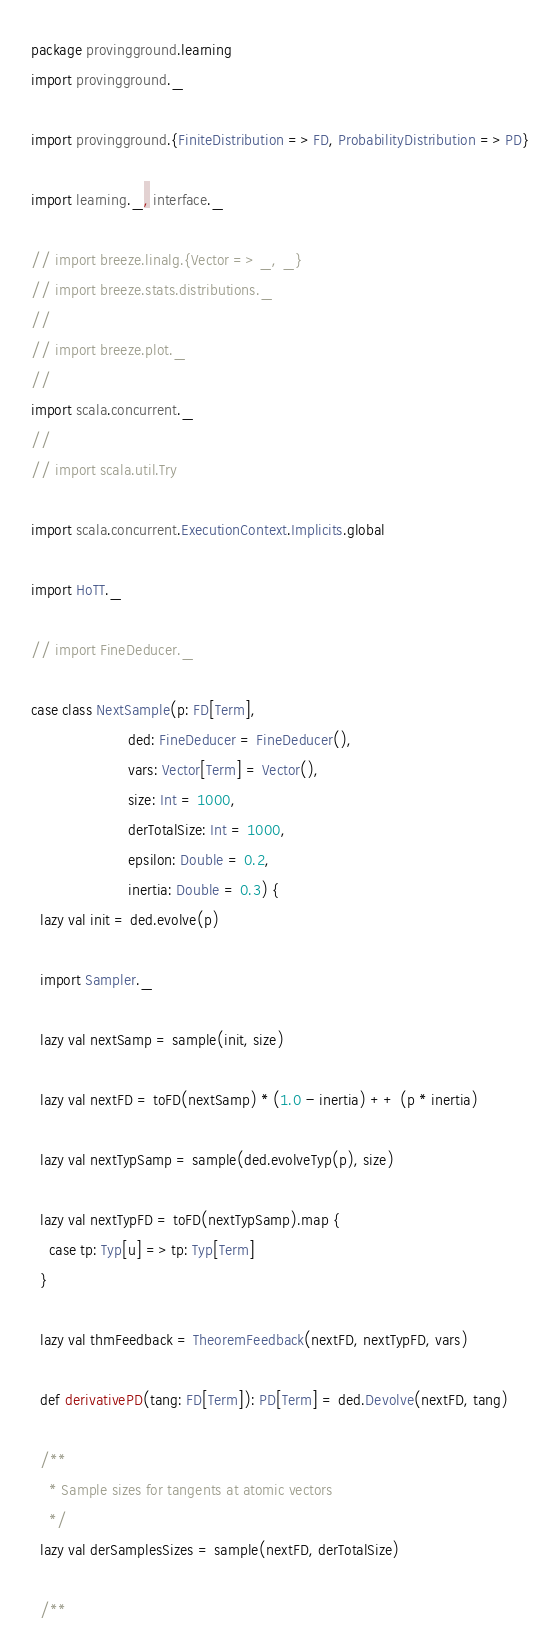Convert code to text. <code><loc_0><loc_0><loc_500><loc_500><_Scala_>package provingground.learning
import provingground._

import provingground.{FiniteDistribution => FD, ProbabilityDistribution => PD}

import learning._, interface._

// import breeze.linalg.{Vector => _, _}
// import breeze.stats.distributions._
//
// import breeze.plot._
//
import scala.concurrent._
//
// import scala.util.Try

import scala.concurrent.ExecutionContext.Implicits.global

import HoTT._

// import FineDeducer._

case class NextSample(p: FD[Term],
                      ded: FineDeducer = FineDeducer(),
                      vars: Vector[Term] = Vector(),
                      size: Int = 1000,
                      derTotalSize: Int = 1000,
                      epsilon: Double = 0.2,
                      inertia: Double = 0.3) {
  lazy val init = ded.evolve(p)

  import Sampler._

  lazy val nextSamp = sample(init, size)

  lazy val nextFD = toFD(nextSamp) * (1.0 - inertia) ++ (p * inertia)

  lazy val nextTypSamp = sample(ded.evolveTyp(p), size)

  lazy val nextTypFD = toFD(nextTypSamp).map {
    case tp: Typ[u] => tp: Typ[Term]
  }

  lazy val thmFeedback = TheoremFeedback(nextFD, nextTypFD, vars)

  def derivativePD(tang: FD[Term]): PD[Term] = ded.Devolve(nextFD, tang)

  /**
    * Sample sizes for tangents at atomic vectors
    */
  lazy val derSamplesSizes = sample(nextFD, derTotalSize)

  /**</code> 